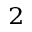Convert formula to latex. <formula><loc_0><loc_0><loc_500><loc_500>^ { 2 }</formula> 